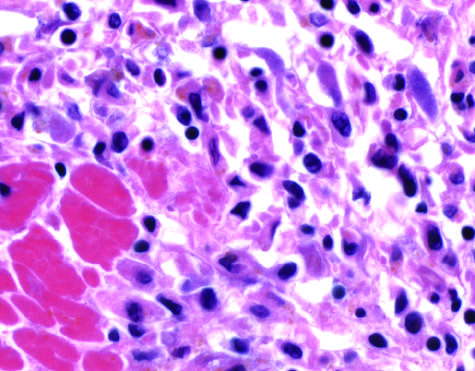do the meninges show an inflammatory reaction in the myocardium after ischemic necrosis infarction?
Answer the question using a single word or phrase. No 